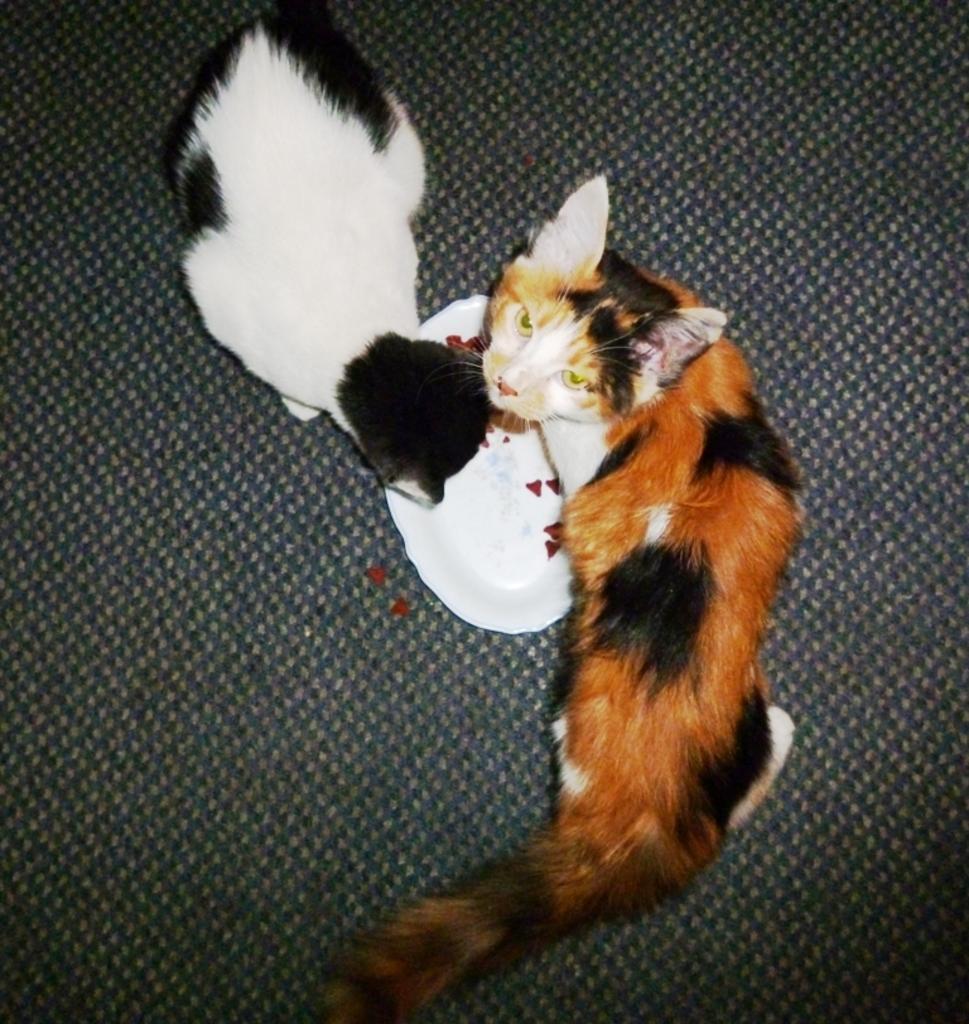Could you give a brief overview of what you see in this image? In this picture we can see two cats and a plate on the path. 